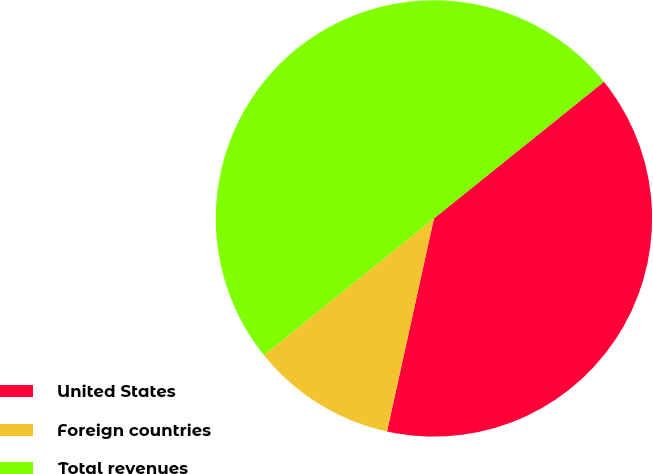Convert chart. <chart><loc_0><loc_0><loc_500><loc_500><pie_chart><fcel>United States<fcel>Foreign countries<fcel>Total revenues<nl><fcel>39.23%<fcel>10.77%<fcel>50.0%<nl></chart> 